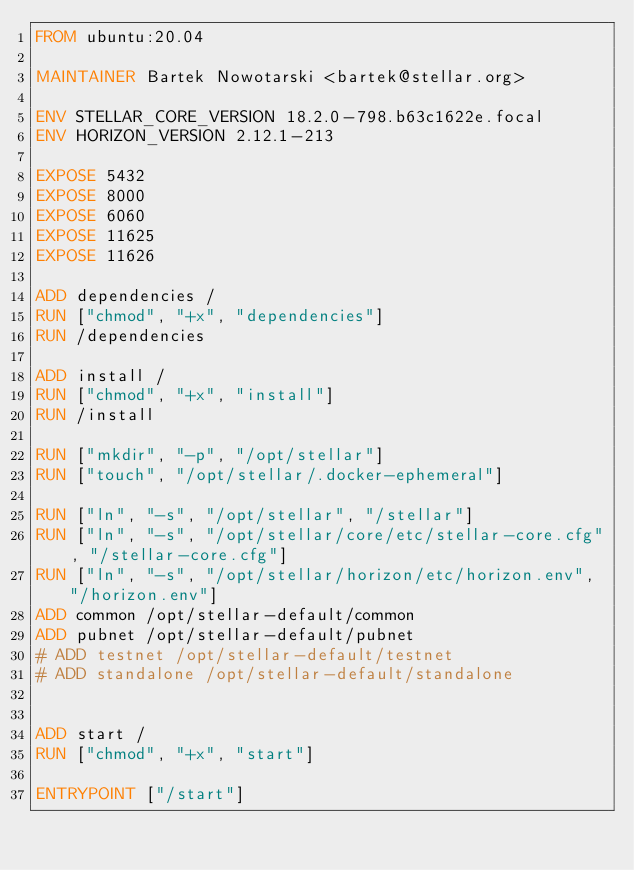<code> <loc_0><loc_0><loc_500><loc_500><_Dockerfile_>FROM ubuntu:20.04

MAINTAINER Bartek Nowotarski <bartek@stellar.org>

ENV STELLAR_CORE_VERSION 18.2.0-798.b63c1622e.focal
ENV HORIZON_VERSION 2.12.1-213

EXPOSE 5432
EXPOSE 8000
EXPOSE 6060
EXPOSE 11625
EXPOSE 11626

ADD dependencies /
RUN ["chmod", "+x", "dependencies"]
RUN /dependencies

ADD install /
RUN ["chmod", "+x", "install"]
RUN /install

RUN ["mkdir", "-p", "/opt/stellar"]
RUN ["touch", "/opt/stellar/.docker-ephemeral"]

RUN ["ln", "-s", "/opt/stellar", "/stellar"]
RUN ["ln", "-s", "/opt/stellar/core/etc/stellar-core.cfg", "/stellar-core.cfg"]
RUN ["ln", "-s", "/opt/stellar/horizon/etc/horizon.env", "/horizon.env"]
ADD common /opt/stellar-default/common
ADD pubnet /opt/stellar-default/pubnet
# ADD testnet /opt/stellar-default/testnet
# ADD standalone /opt/stellar-default/standalone


ADD start /
RUN ["chmod", "+x", "start"]

ENTRYPOINT ["/start"]
</code> 